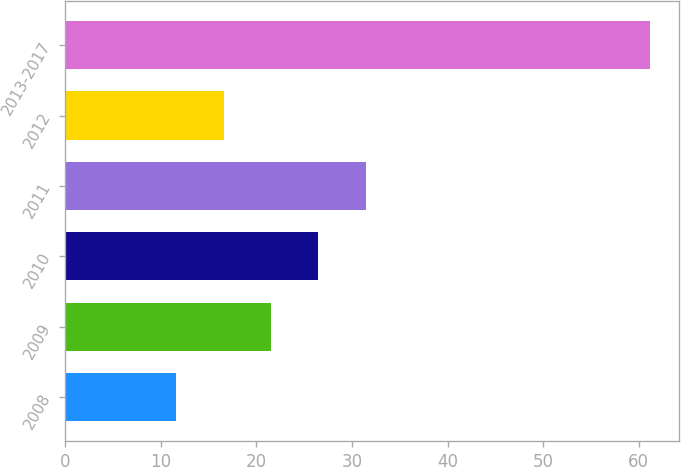<chart> <loc_0><loc_0><loc_500><loc_500><bar_chart><fcel>2008<fcel>2009<fcel>2010<fcel>2011<fcel>2012<fcel>2013-2017<nl><fcel>11.6<fcel>21.52<fcel>26.48<fcel>31.44<fcel>16.56<fcel>61.2<nl></chart> 